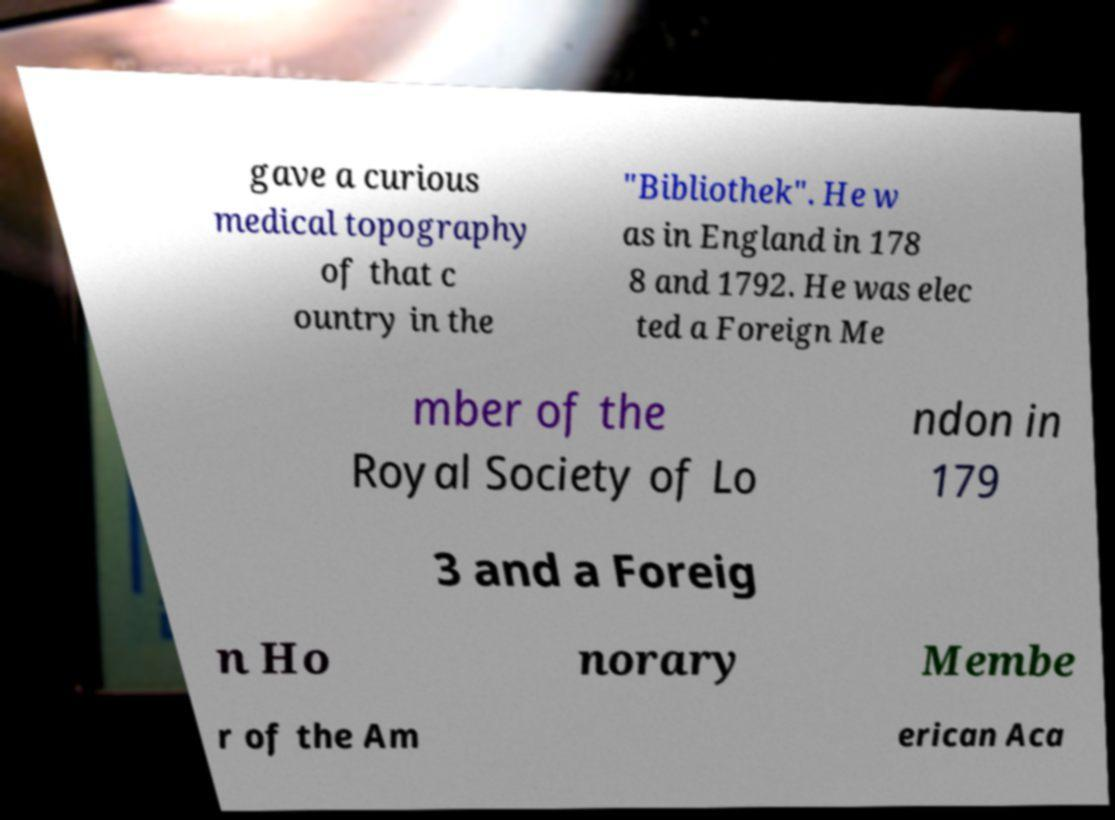There's text embedded in this image that I need extracted. Can you transcribe it verbatim? gave a curious medical topography of that c ountry in the "Bibliothek". He w as in England in 178 8 and 1792. He was elec ted a Foreign Me mber of the Royal Society of Lo ndon in 179 3 and a Foreig n Ho norary Membe r of the Am erican Aca 